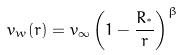<formula> <loc_0><loc_0><loc_500><loc_500>v _ { w } ( r ) = v _ { \infty } \left ( 1 - \frac { R _ { ^ { * } } } { r } \right ) ^ { \beta }</formula> 